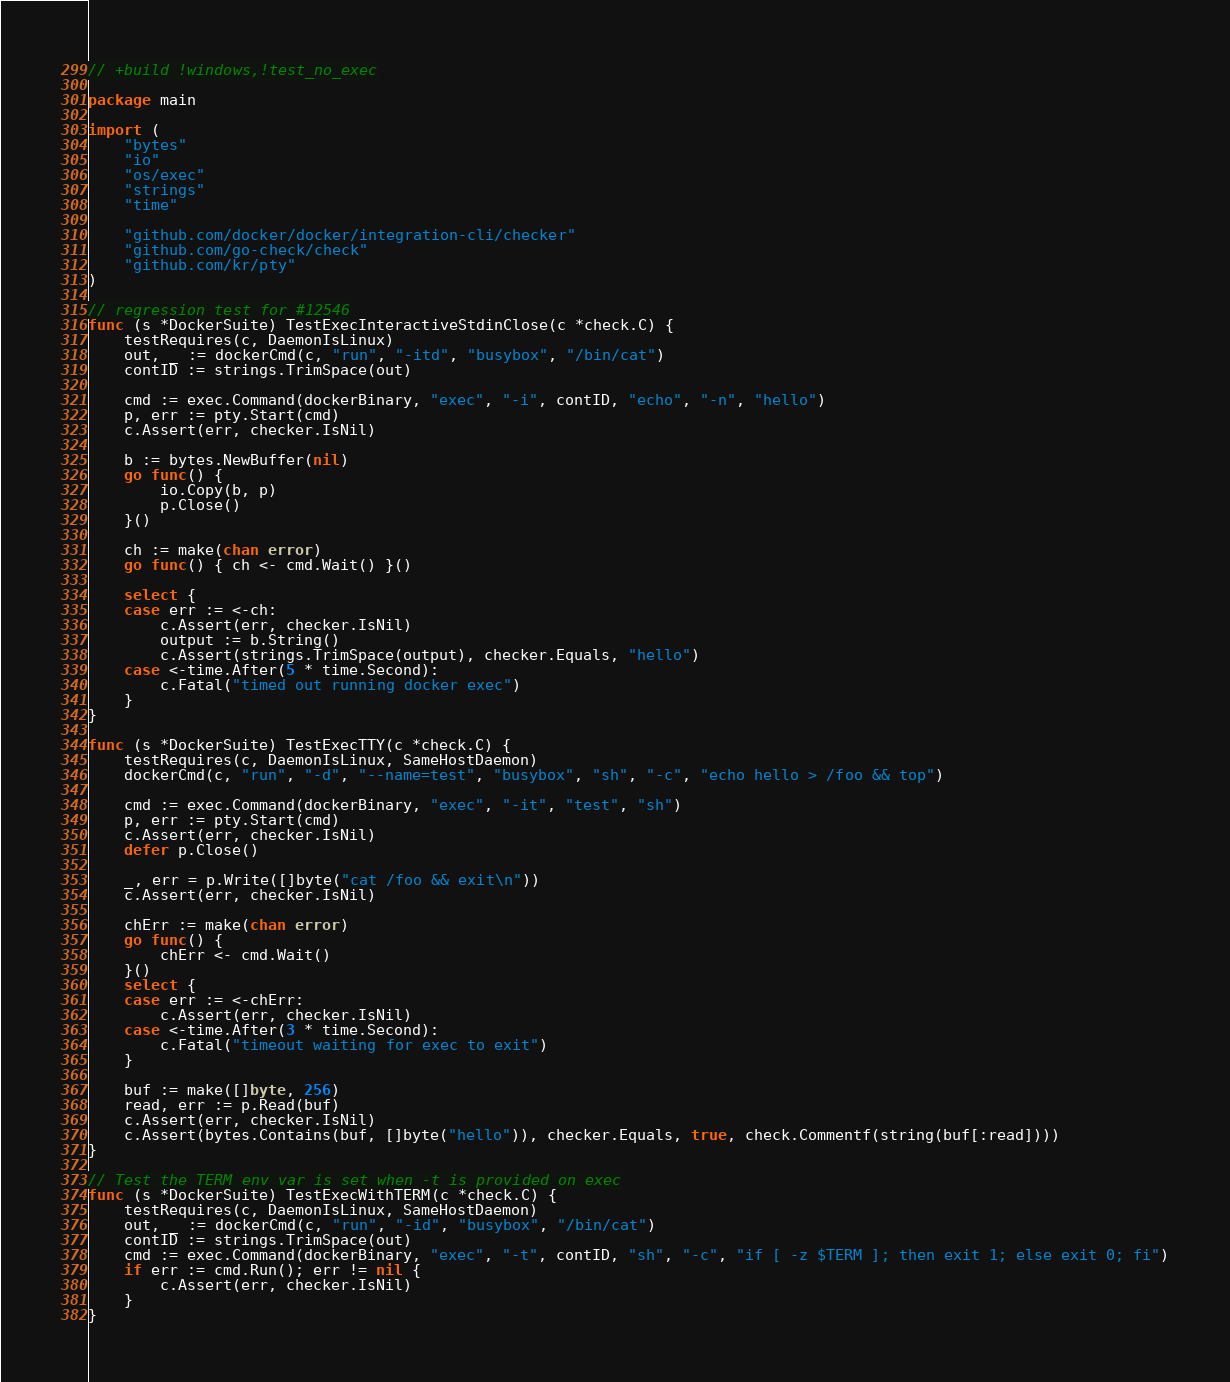<code> <loc_0><loc_0><loc_500><loc_500><_Go_>// +build !windows,!test_no_exec

package main

import (
	"bytes"
	"io"
	"os/exec"
	"strings"
	"time"

	"github.com/docker/docker/integration-cli/checker"
	"github.com/go-check/check"
	"github.com/kr/pty"
)

// regression test for #12546
func (s *DockerSuite) TestExecInteractiveStdinClose(c *check.C) {
	testRequires(c, DaemonIsLinux)
	out, _ := dockerCmd(c, "run", "-itd", "busybox", "/bin/cat")
	contID := strings.TrimSpace(out)

	cmd := exec.Command(dockerBinary, "exec", "-i", contID, "echo", "-n", "hello")
	p, err := pty.Start(cmd)
	c.Assert(err, checker.IsNil)

	b := bytes.NewBuffer(nil)
	go func() {
		io.Copy(b, p)
		p.Close()
	}()

	ch := make(chan error)
	go func() { ch <- cmd.Wait() }()

	select {
	case err := <-ch:
		c.Assert(err, checker.IsNil)
		output := b.String()
		c.Assert(strings.TrimSpace(output), checker.Equals, "hello")
	case <-time.After(5 * time.Second):
		c.Fatal("timed out running docker exec")
	}
}

func (s *DockerSuite) TestExecTTY(c *check.C) {
	testRequires(c, DaemonIsLinux, SameHostDaemon)
	dockerCmd(c, "run", "-d", "--name=test", "busybox", "sh", "-c", "echo hello > /foo && top")

	cmd := exec.Command(dockerBinary, "exec", "-it", "test", "sh")
	p, err := pty.Start(cmd)
	c.Assert(err, checker.IsNil)
	defer p.Close()

	_, err = p.Write([]byte("cat /foo && exit\n"))
	c.Assert(err, checker.IsNil)

	chErr := make(chan error)
	go func() {
		chErr <- cmd.Wait()
	}()
	select {
	case err := <-chErr:
		c.Assert(err, checker.IsNil)
	case <-time.After(3 * time.Second):
		c.Fatal("timeout waiting for exec to exit")
	}

	buf := make([]byte, 256)
	read, err := p.Read(buf)
	c.Assert(err, checker.IsNil)
	c.Assert(bytes.Contains(buf, []byte("hello")), checker.Equals, true, check.Commentf(string(buf[:read])))
}

// Test the TERM env var is set when -t is provided on exec
func (s *DockerSuite) TestExecWithTERM(c *check.C) {
	testRequires(c, DaemonIsLinux, SameHostDaemon)
	out, _ := dockerCmd(c, "run", "-id", "busybox", "/bin/cat")
	contID := strings.TrimSpace(out)
	cmd := exec.Command(dockerBinary, "exec", "-t", contID, "sh", "-c", "if [ -z $TERM ]; then exit 1; else exit 0; fi")
	if err := cmd.Run(); err != nil {
		c.Assert(err, checker.IsNil)
	}
}
</code> 